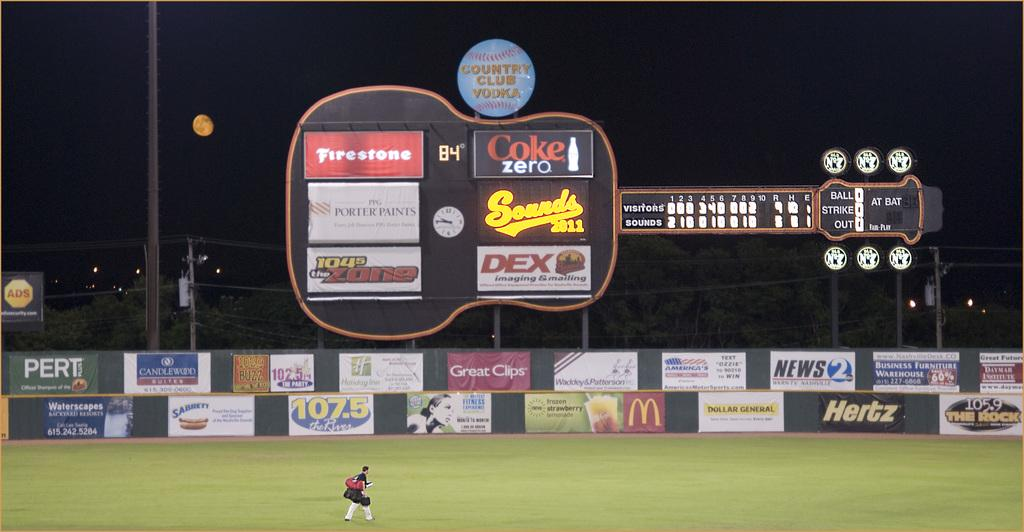<image>
Write a terse but informative summary of the picture. A baseball score board shaped like a guitar with a variety of advertising signs on the score board and on the fence below it. 